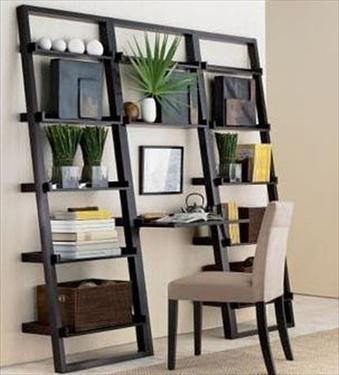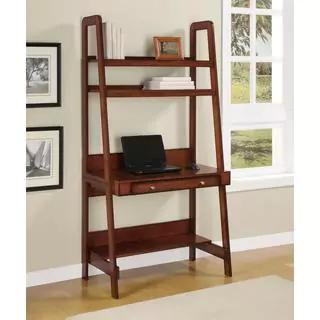The first image is the image on the left, the second image is the image on the right. Considering the images on both sides, is "A silver colored laptop is sitting on a black desk that is connected to an entertainment center." valid? Answer yes or no. No. The first image is the image on the left, the second image is the image on the right. For the images shown, is this caption "Both images contain laptops." true? Answer yes or no. No. 